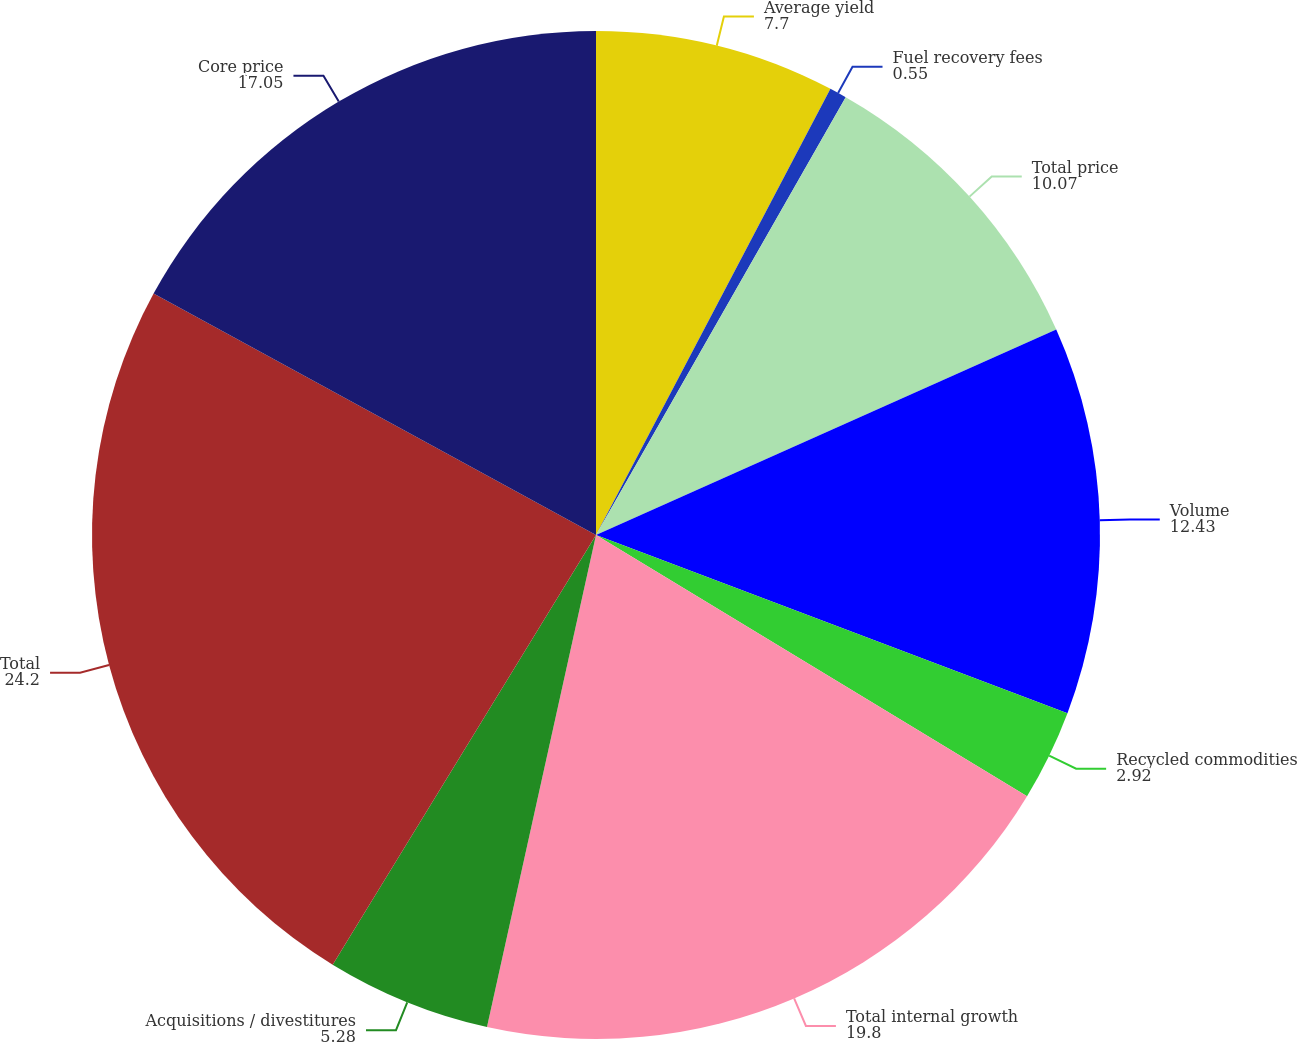Convert chart. <chart><loc_0><loc_0><loc_500><loc_500><pie_chart><fcel>Average yield<fcel>Fuel recovery fees<fcel>Total price<fcel>Volume<fcel>Recycled commodities<fcel>Total internal growth<fcel>Acquisitions / divestitures<fcel>Total<fcel>Core price<nl><fcel>7.7%<fcel>0.55%<fcel>10.07%<fcel>12.43%<fcel>2.92%<fcel>19.8%<fcel>5.28%<fcel>24.2%<fcel>17.05%<nl></chart> 